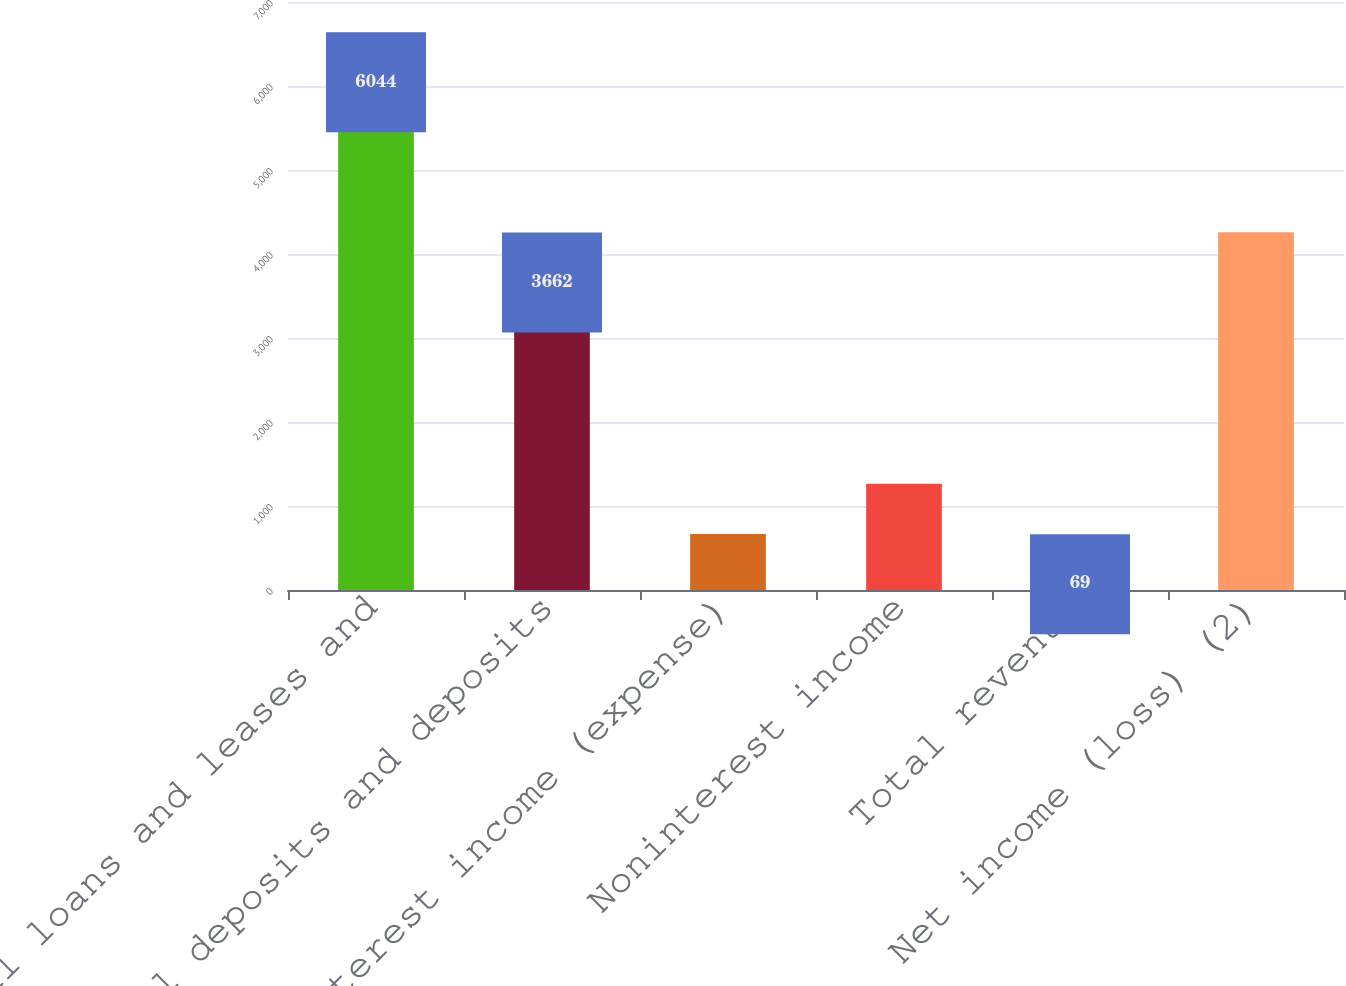<chart> <loc_0><loc_0><loc_500><loc_500><bar_chart><fcel>Total loans and leases and<fcel>Total deposits and deposits<fcel>Net interest income (expense)<fcel>Noninterest income<fcel>Total revenue<fcel>Net income (loss) (2)<nl><fcel>6044<fcel>3662<fcel>666.5<fcel>1264<fcel>69<fcel>4259.5<nl></chart> 